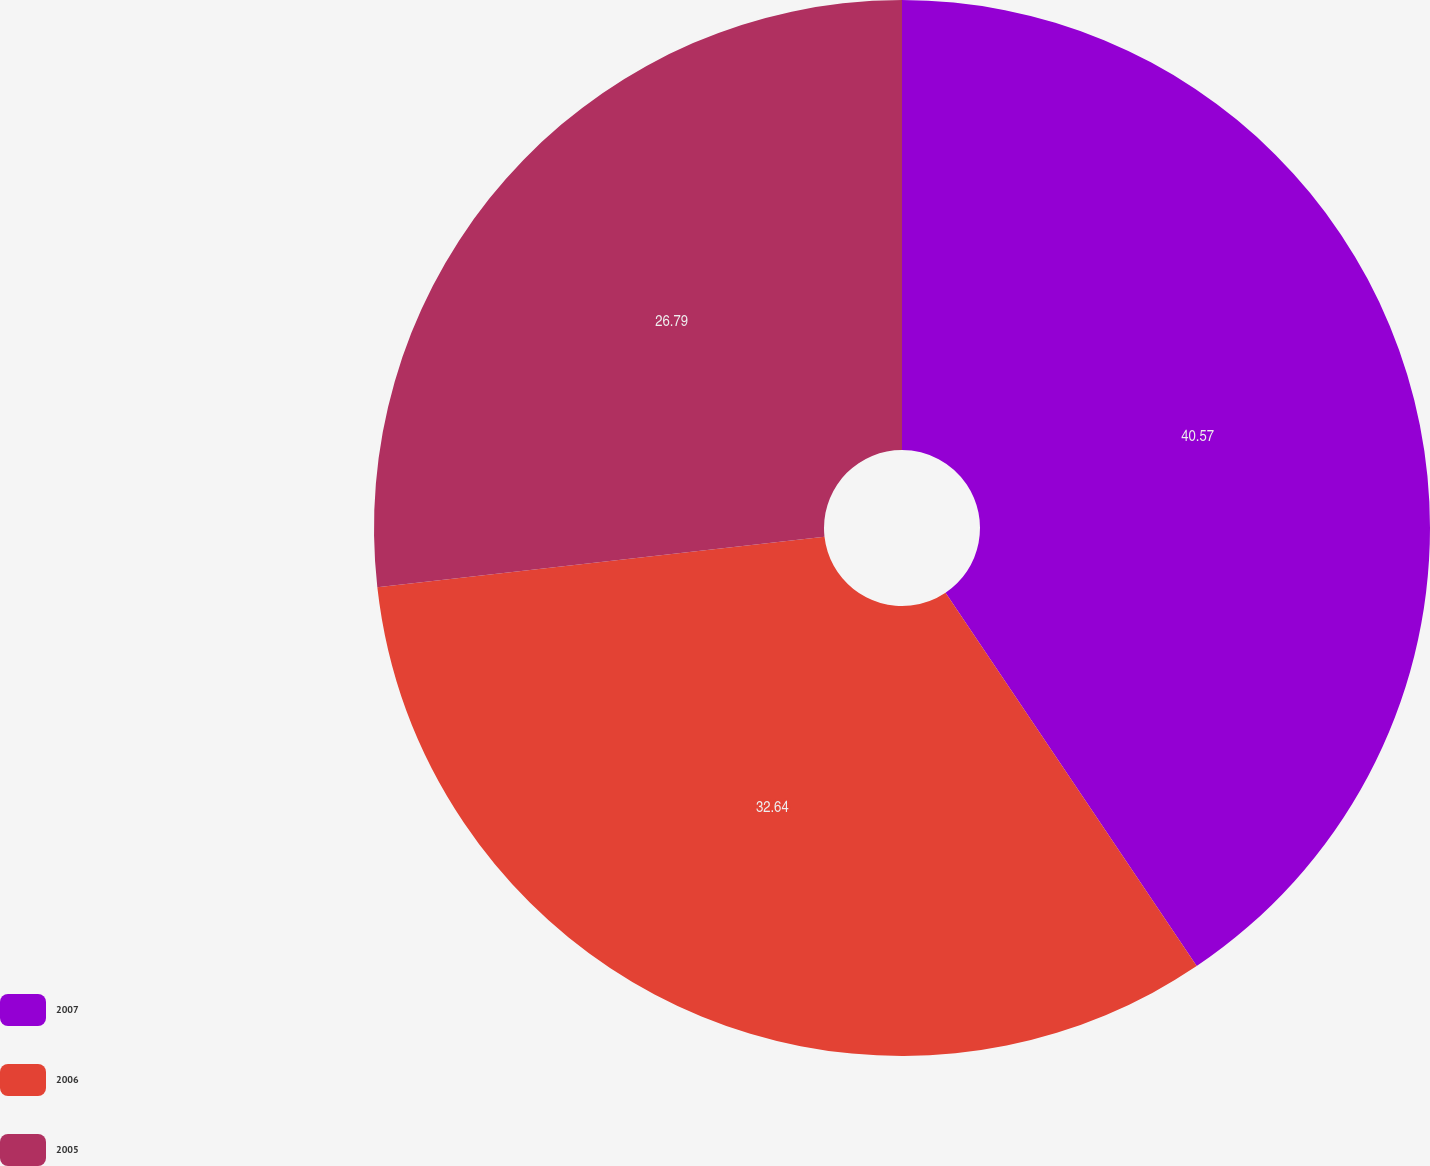Convert chart. <chart><loc_0><loc_0><loc_500><loc_500><pie_chart><fcel>2007<fcel>2006<fcel>2005<nl><fcel>40.58%<fcel>32.64%<fcel>26.79%<nl></chart> 